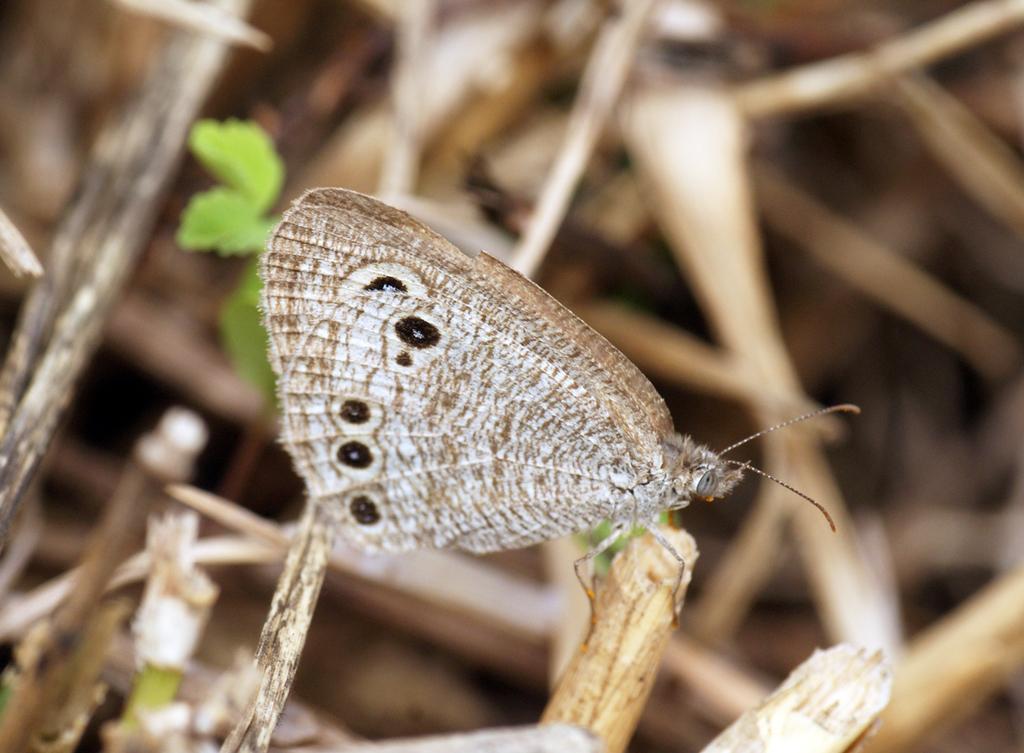Describe this image in one or two sentences. This image consists of a butterfly in brown color is sitting on a stem. In the background, there are plants along with leaves. 